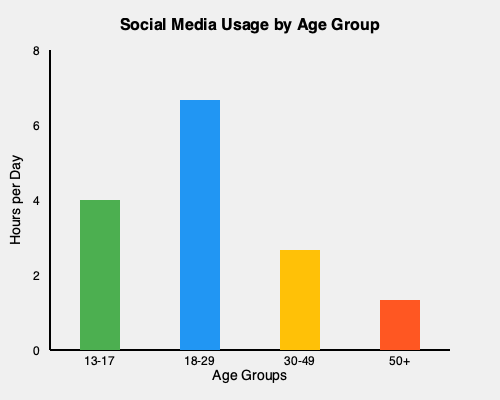As a parent concerned about your children's social media usage, which age group shows the highest average daily social media use, and how might this information guide your approach to discussing digital habits with your teenagers? To answer this question, let's analyze the bar graph step-by-step:

1. The graph shows social media usage across four age groups: 13-17, 18-29, 30-49, and 50+.

2. The y-axis represents hours per day spent on social media.

3. Examining each age group:
   - 13-17: Approximately 4 hours per day
   - 18-29: Approximately 6 hours per day
   - 30-49: Approximately 2.5 hours per day
   - 50+: Approximately 1 hour per day

4. The age group with the highest average daily social media use is 18-29, with about 6 hours per day.

5. As a parent of teenagers (likely in the 13-17 age group), this information is valuable for several reasons:
   a. It shows that your teens' age group uses social media less than young adults, but still significantly (about 4 hours daily).
   b. There's a potential for increased usage as they enter the 18-29 age range.
   c. The data provides a factual basis for discussions about healthy digital habits.

6. This information can guide your approach by:
   a. Acknowledging that social media is a significant part of your teens' lives.
   b. Discussing the potential impacts of excessive use, especially as they approach young adulthood.
   c. Encouraging a balanced approach to social media use, perhaps setting goals to maintain or reduce current usage levels.
   d. Using the data to set realistic expectations and guidelines for social media use in your household.
Answer: 18-29 age group; use data to discuss balanced social media habits with teens, acknowledging current usage and potential for increase. 